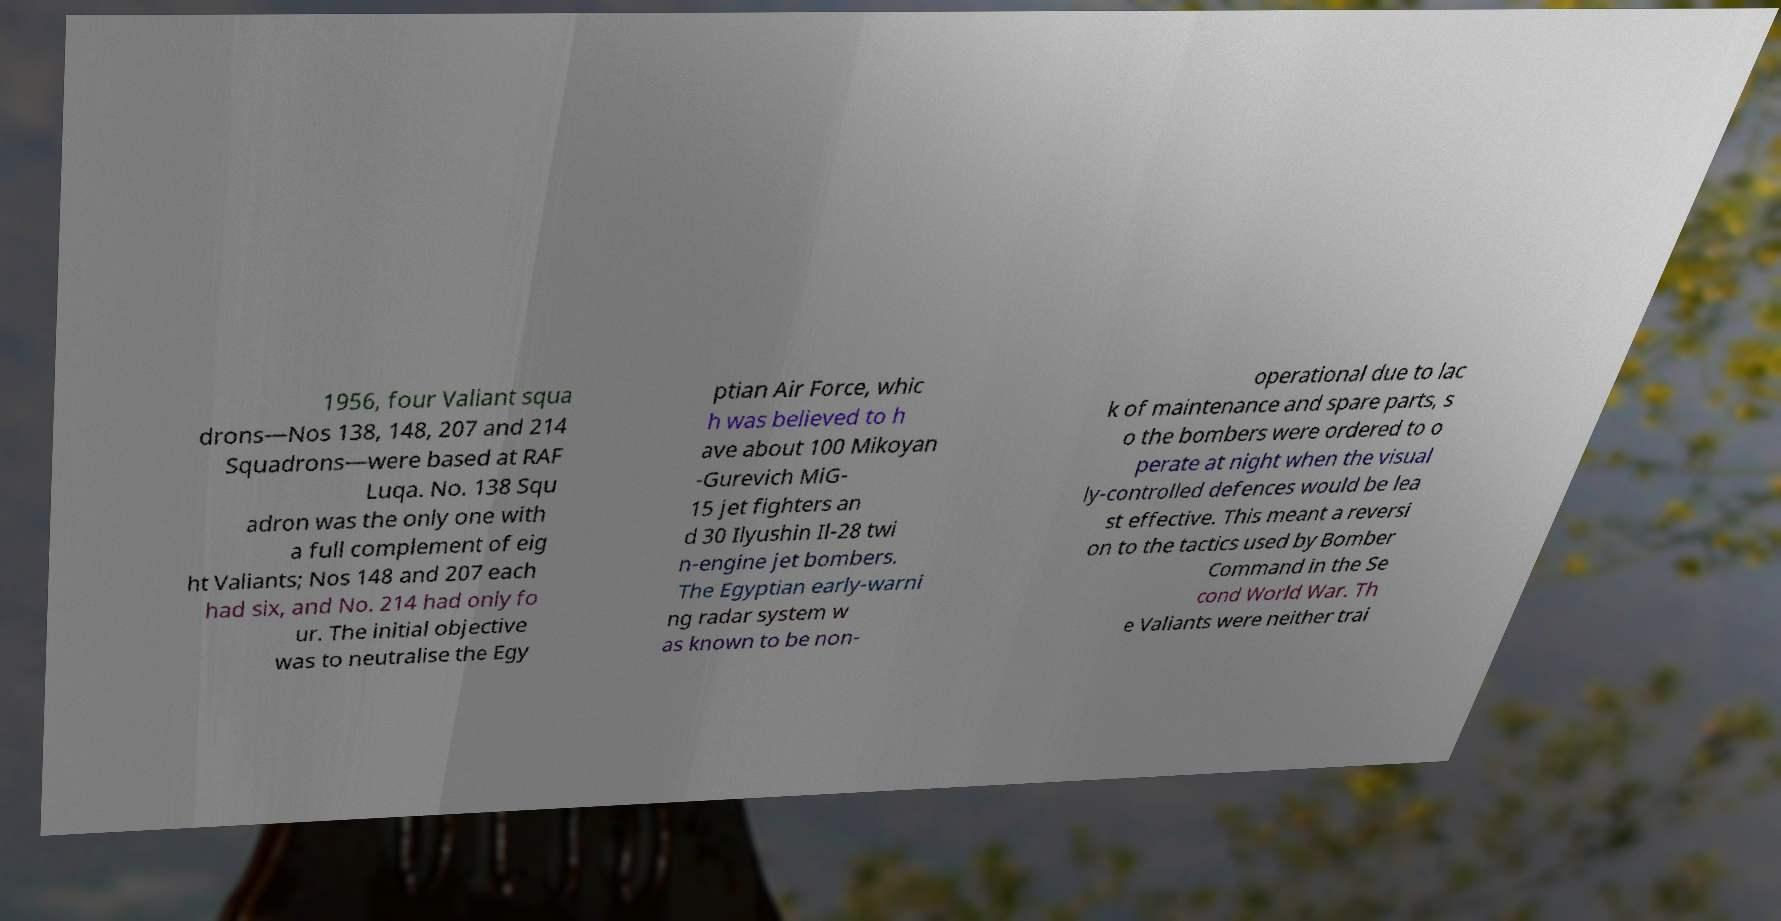There's text embedded in this image that I need extracted. Can you transcribe it verbatim? 1956, four Valiant squa drons—Nos 138, 148, 207 and 214 Squadrons—were based at RAF Luqa. No. 138 Squ adron was the only one with a full complement of eig ht Valiants; Nos 148 and 207 each had six, and No. 214 had only fo ur. The initial objective was to neutralise the Egy ptian Air Force, whic h was believed to h ave about 100 Mikoyan -Gurevich MiG- 15 jet fighters an d 30 Ilyushin Il-28 twi n-engine jet bombers. The Egyptian early-warni ng radar system w as known to be non- operational due to lac k of maintenance and spare parts, s o the bombers were ordered to o perate at night when the visual ly-controlled defences would be lea st effective. This meant a reversi on to the tactics used by Bomber Command in the Se cond World War. Th e Valiants were neither trai 